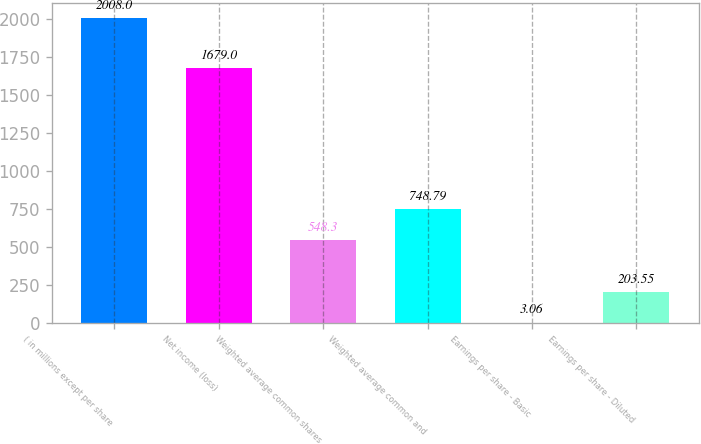Convert chart. <chart><loc_0><loc_0><loc_500><loc_500><bar_chart><fcel>( in millions except per share<fcel>Net income (loss)<fcel>Weighted average common shares<fcel>Weighted average common and<fcel>Earnings per share - Basic<fcel>Earnings per share - Diluted<nl><fcel>2008<fcel>1679<fcel>548.3<fcel>748.79<fcel>3.06<fcel>203.55<nl></chart> 